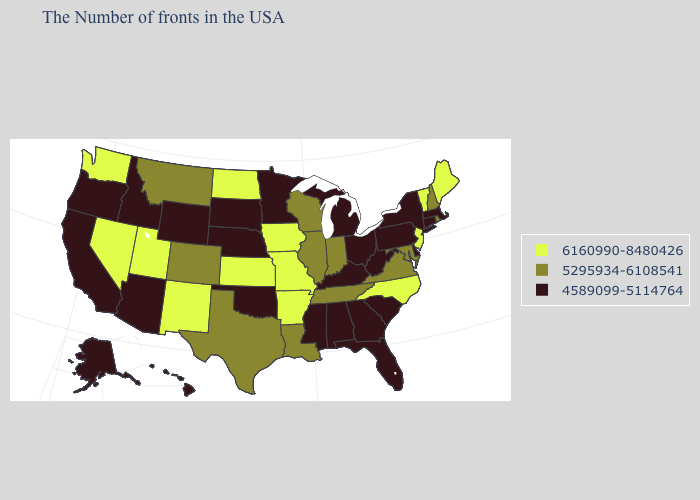What is the value of New Hampshire?
Concise answer only. 5295934-6108541. Among the states that border Delaware , which have the highest value?
Concise answer only. New Jersey. What is the value of South Dakota?
Quick response, please. 4589099-5114764. Does Indiana have the lowest value in the MidWest?
Write a very short answer. No. Among the states that border Oklahoma , does New Mexico have the highest value?
Be succinct. Yes. What is the value of Maryland?
Give a very brief answer. 5295934-6108541. Does the map have missing data?
Short answer required. No. Name the states that have a value in the range 5295934-6108541?
Short answer required. Rhode Island, New Hampshire, Maryland, Virginia, Indiana, Tennessee, Wisconsin, Illinois, Louisiana, Texas, Colorado, Montana. What is the highest value in states that border Iowa?
Answer briefly. 6160990-8480426. Does Tennessee have the highest value in the USA?
Keep it brief. No. What is the value of Georgia?
Write a very short answer. 4589099-5114764. What is the value of Idaho?
Answer briefly. 4589099-5114764. Which states have the lowest value in the Northeast?
Quick response, please. Massachusetts, Connecticut, New York, Pennsylvania. Is the legend a continuous bar?
Quick response, please. No. What is the value of Florida?
Keep it brief. 4589099-5114764. 